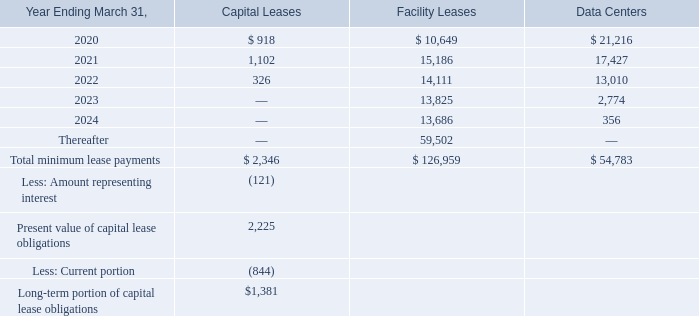12. Commitments and Contingencies
The Company leases its facilities under non-cancelable operating leases and build-to-suit leases with various expiration dates through March 2029. Rent expense related to the Company’s office facilities was $5.3 million, $4.8 million and $3.2 million for the years ended March 31, 2019, 2018 and 2017, respectively. The Company has also entered into various capital lease agreements for computer equipment with non-cancelable terms through January 2022 and has non-cancelable commitments related to its data centers.
Future minimum payments for our capital leases, facility operating leases (including Lexington MA – U.S. build-to-suit lease) and data center operating leases as of March 31, 2019 are as follows:
Certain amounts included in the table above relating to data center operating leases for the Company’s servers include usage-based charges in addition to base rent.
Future lease payments in the table above do not include amounts due to the Company for future minimum sublease rental income of $0.6 million under non-cancelable subleases through 2020.
The Company has outstanding letters of credit of $3.9 million and $3.8 million related to certain operating leases as of March 31, 2019 and 2018, respectively.
How much was the outstanding letters of credit related to certain operating leases as of March 31, 2019? $3.9 million. How much was the outstanding letters of credit related to certain operating leases as of March 31, 2018? $3.8 million. How much was the Rent expense related to the Company’s office facilities for the years ended March 31, 2019, 2018 and 2017 respectively? $5.3 million, $4.8 million, $3.2 million. What is the change in Facility Leases from Year Ending March 31, 2021 to 2022? 14,111-15,186
Answer: -1075. What is the change in Facility Leases from Year Ending March 31, 2022 to 2023? 13,825-14,111
Answer: -286. What is the change in Facility Leases from Year Ending March 31, 2023 to 2024? 13,686-13,825
Answer: -139. 